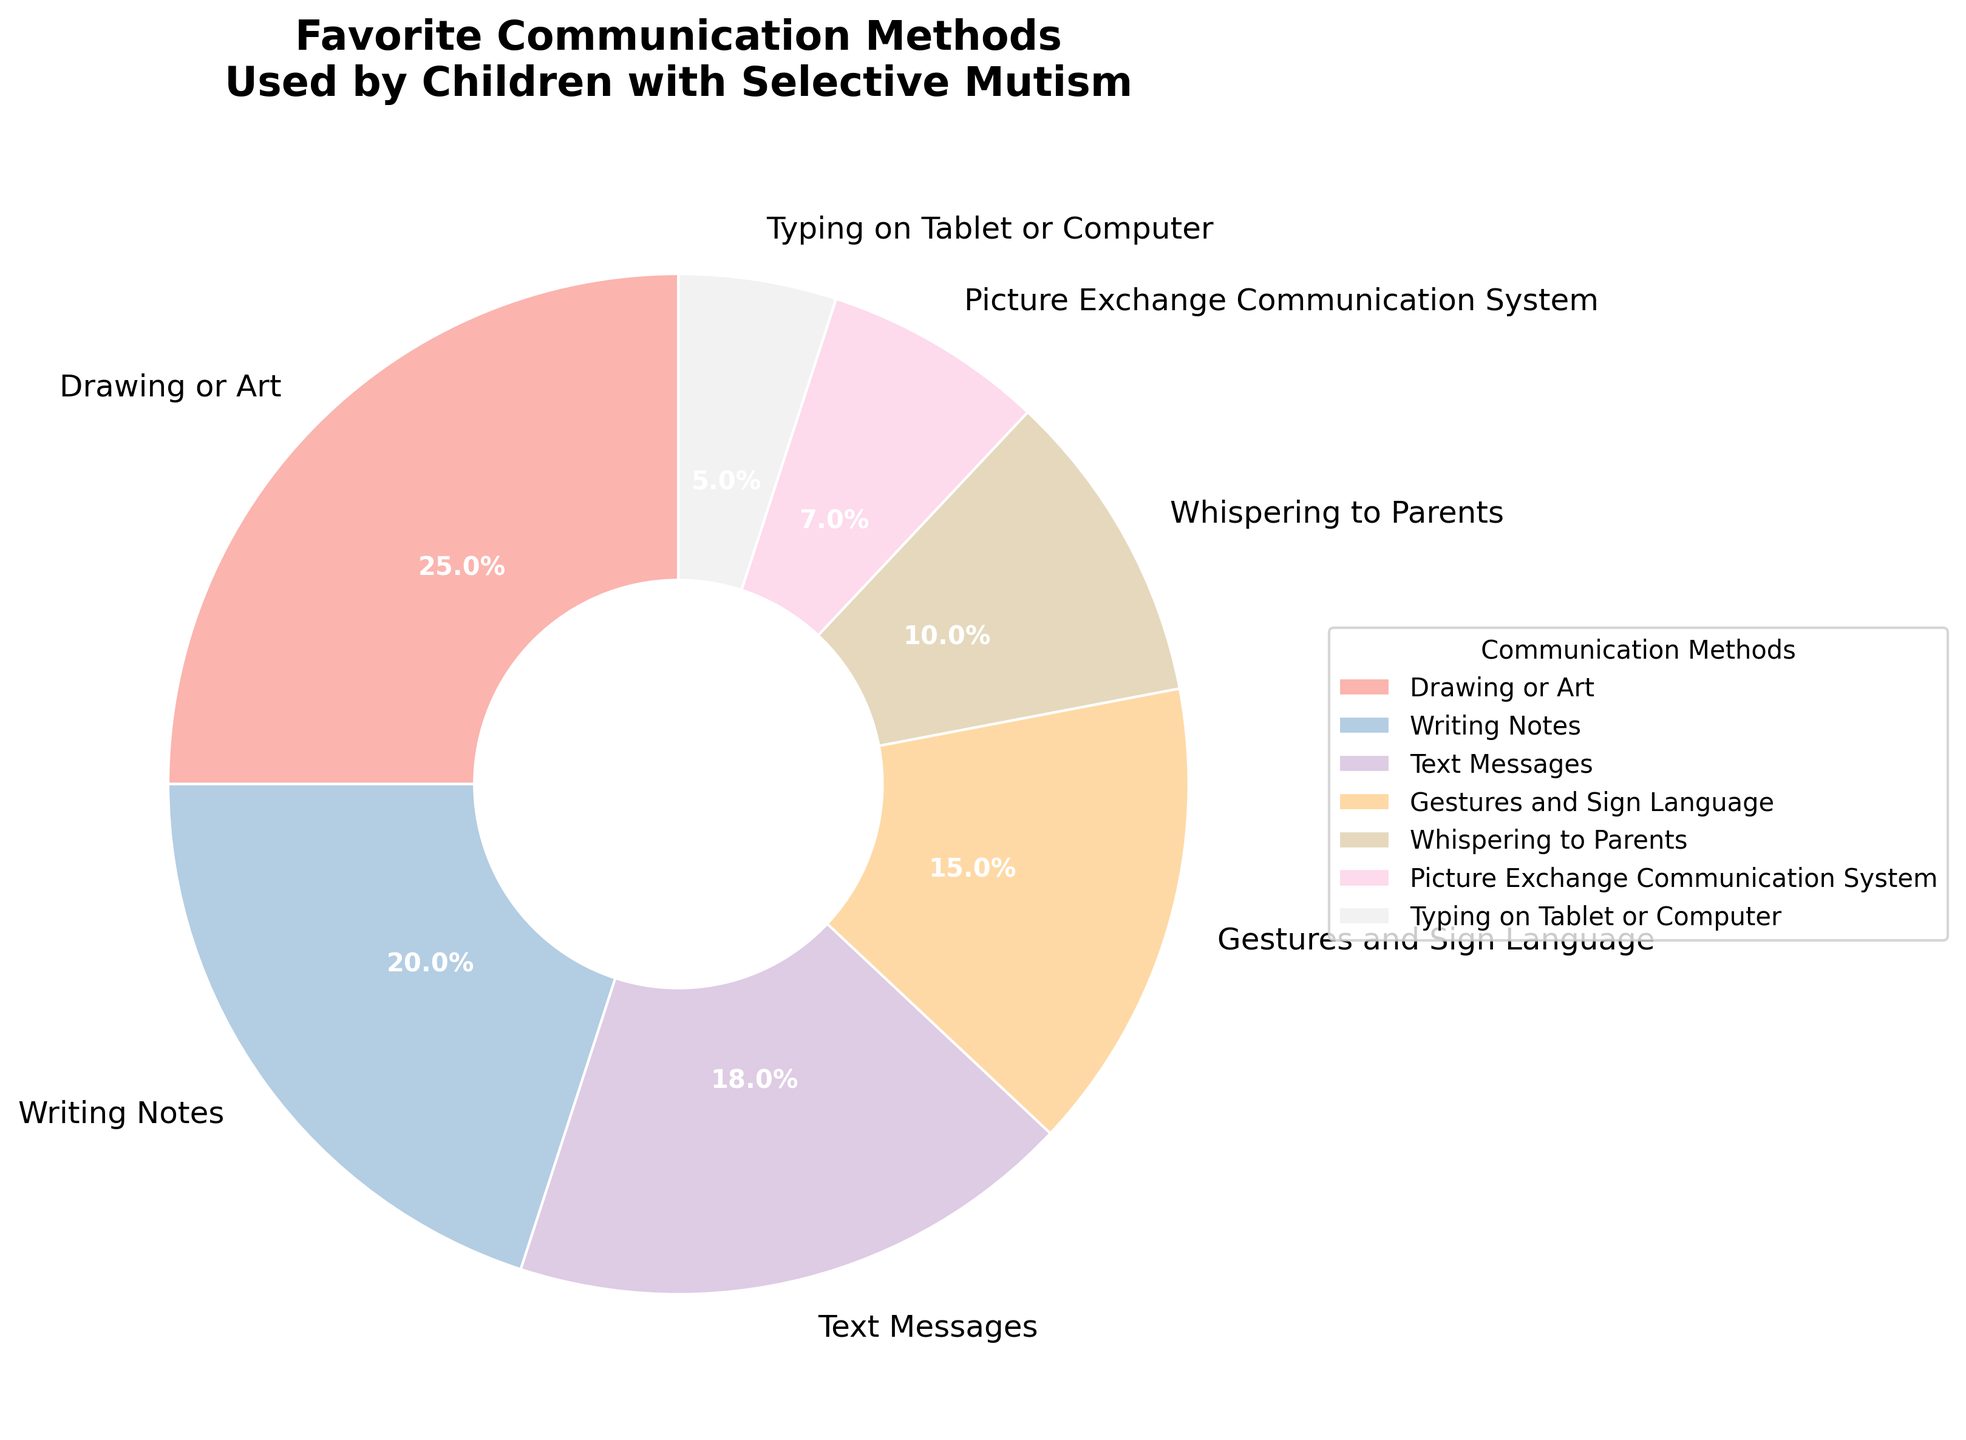Which communication method is the most favored by children with selective mutism? The most favored communication method is the one with the largest slice in the pie chart. The largest slice represents Drawing or Art at 25%.
Answer: Drawing or Art What is the combined percentage of children using Text Messages and Writing Notes? Add the percentages of Text Messages (18%) and Writing Notes (20%). \(18\% + 20\% = 38\%\)
Answer: 38% Which method accounts for a smaller percentage, Gestures and Sign Language or Whispering to Parents? Compare the slices for Gestures and Sign Language (15%) with Whispering to Parents (10%). 10% is smaller than 15%.
Answer: Whispering to Parents What methods have a percentage higher than 15% but less than 25%? Look for slices where the percentage is more than 15% and less than 25%. This condition matches Writing Notes (20%) and Text Messages (18%).
Answer: Writing Notes and Text Messages How much larger is the percentage for Drawing or Art compared to Typing on Tablet or Computer? Subtract the percentage of Typing on Tablet or Computer (5%) from Drawing or Art (25%). \(25\% - 5\% = 20\%\)
Answer: 20% Which method has the smallest representation? The smallest slice in the pie chart corresponds to Typing on Tablet or Computer at 5%.
Answer: Typing on Tablet or Computer What is the total percentage for methods that use some form of visual communication (Drawing or Art, Writing Notes, and Picture Exchange Communication System)? Add the percentages for Drawing or Art (25%), Writing Notes (20%), and Picture Exchange Communication System (7%). \(25\% + 20\% + 7\% = 52\%\)
Answer: 52% Compare the total percentage of Whispering to Parents and Typing on Tablet or Computer with the percentage of Drawing or Art. Which total is higher? Calculate the total for Whispering to Parents (10%) and Typing on Tablet or Computer (5%), then compare it with Drawing or Art. \(10\% + 5\% = 15\%\). The percentage for Drawing or Art is higher at 25%.
Answer: Drawing or Art What color represents the slice for Text Messages? Identify the color associated with Text Messages in the legend next to its corresponding slice in the pie chart.
Answer: Light Pink (or the specific color used in Pastel1 palette) If you combine the percentages of the top three preferred methods, what is the total percentage? Add the percentages of the top three preferred methods: Drawing or Art (25%), Writing Notes (20%), and Text Messages (18%). \(25\% + 20\% + 18\% = 63\%\)
Answer: 63% 